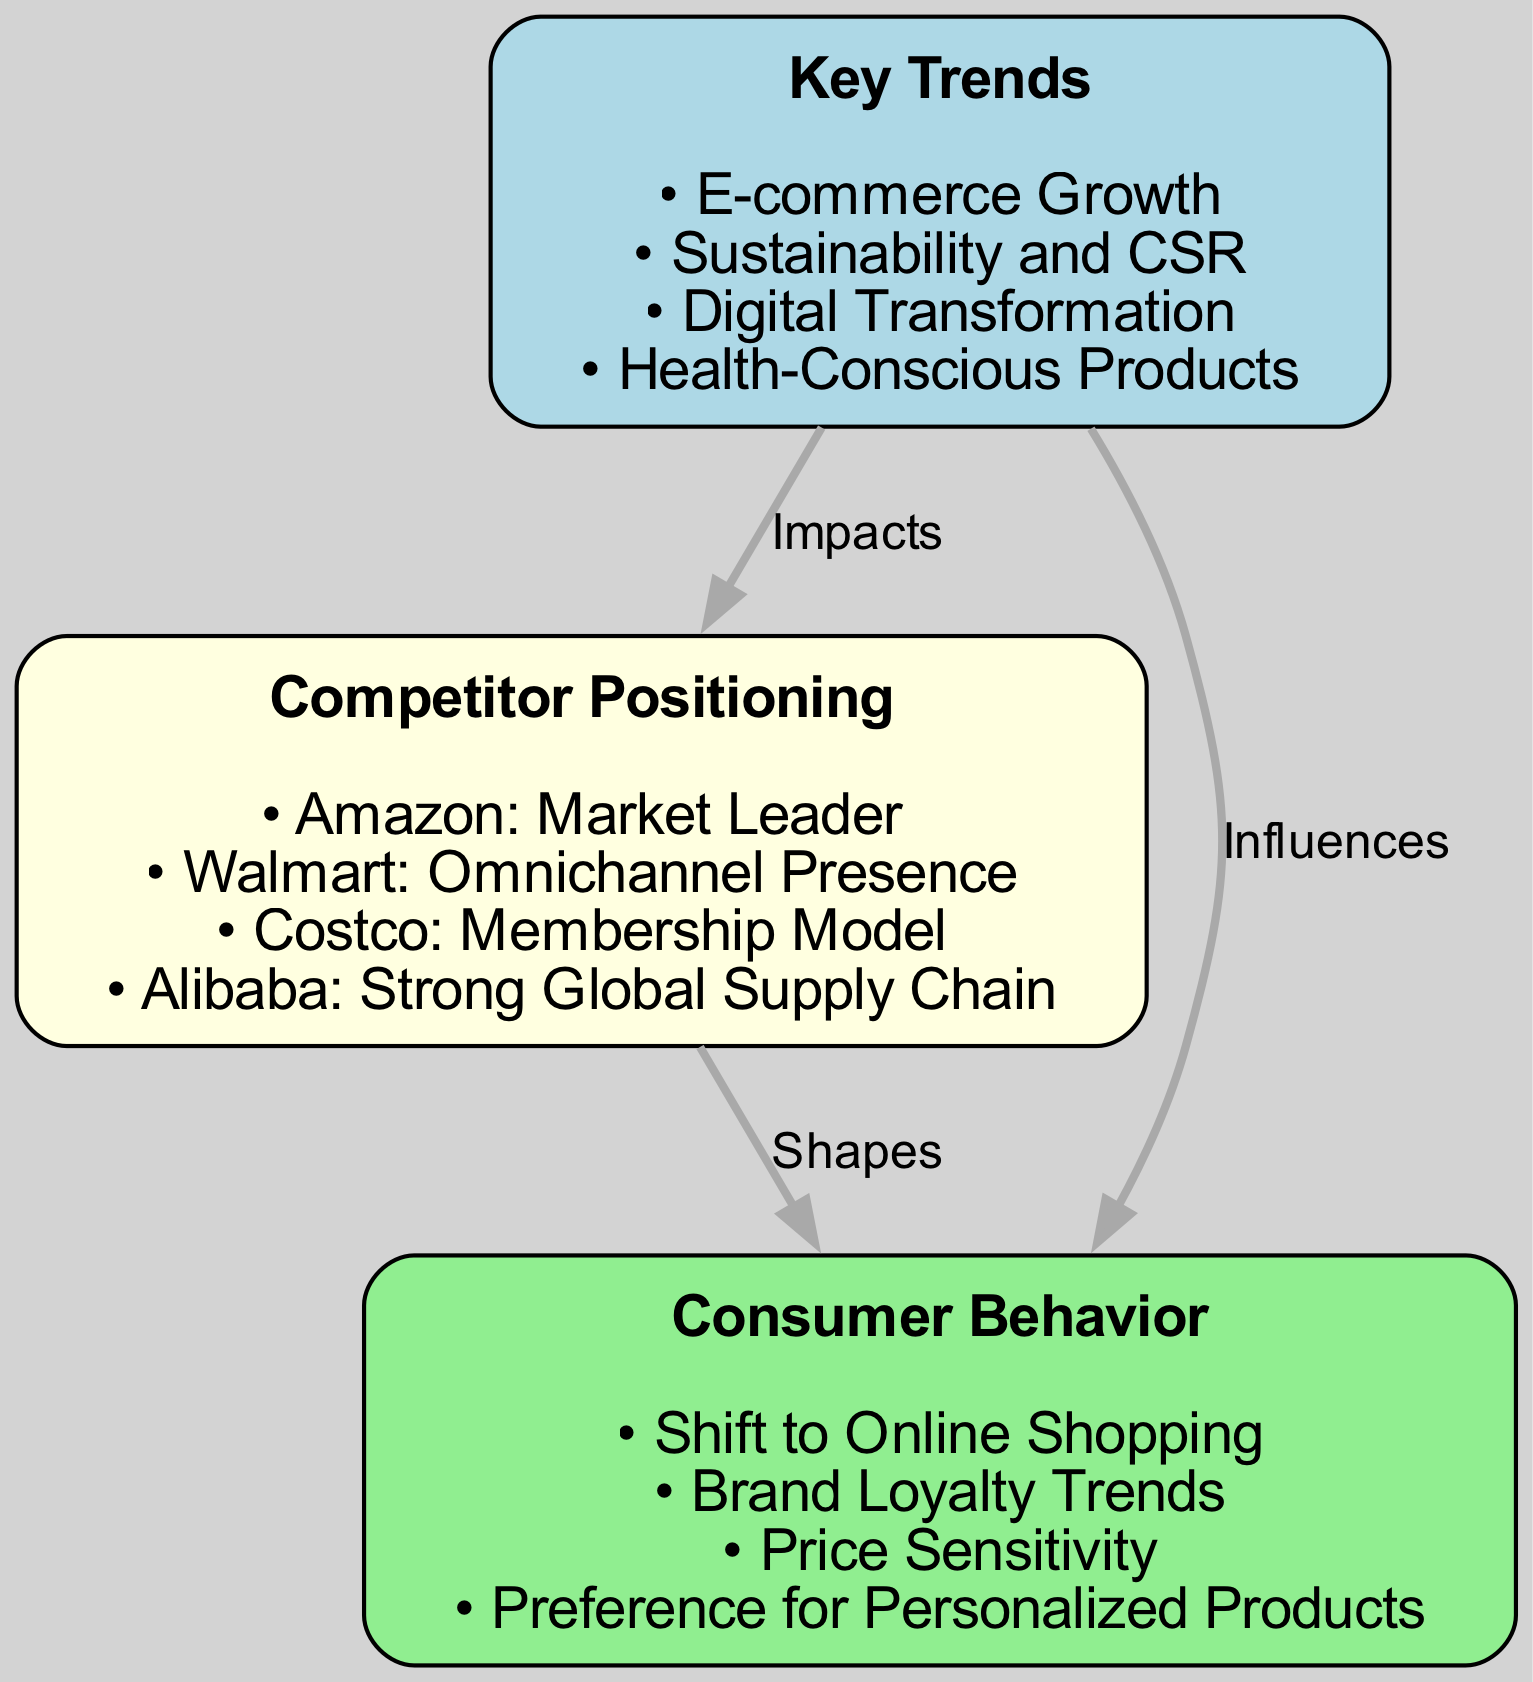What are the four key trends listed in the diagram? The diagram presents four key trends: E-commerce Growth, Sustainability and CSR, Digital Transformation, and Health-Conscious Products. These are directly listed under the "Key Trends" node.
Answer: E-commerce Growth, Sustainability and CSR, Digital Transformation, Health-Conscious Products Who is identified as the market leader in competitor positioning? According to the "Competitor Positioning" node in the diagram, Amazon is recognized as the market leader. This information is explicitly stated in the details of that node.
Answer: Amazon How many edges are present in the diagram? The diagram contains three edges that illustrate relationships between the nodes. This can be confirmed by counting the edges in the edges list provided.
Answer: 3 Which node influences consumer behavior according to the diagram? The diagram specifies that the "Key Trends" node influences the "Consumer Behavior" node, as indicated by the edge labeled "Influences" connecting them.
Answer: Key Trends What is the relationship between Competitor Positioning and Consumer Behavior? The relationship is characterized as "Shapes," indicating that the "Competitor Positioning" node helps to define or influence consumer behavior in the market. This interpretation comes from the edge that connects these two nodes.
Answer: Shapes What is one of the specific consumer behavior trends mentioned? The "Consumer Behavior" node lists several specific trends, one of which is "Shift to Online Shopping." This information can be found in the details under the "Consumer Behavior" node.
Answer: Shift to Online Shopping How does Key Trends impact Competitor Positioning? The diagram indicates that "Key Trends" node impacts the "Competitor Positioning" node, which is shown by the edge labeled "Impacts." This establishes a directional influence from trends to how competitors position themselves in the market.
Answer: Impacts What type of consumer products are increasingly favored according to the trends? One trend highlighted is the preference for "Personalized Products," showing an inclination among consumers towards customization, as stated in the "Consumer Behavior" node.
Answer: Personalized Products Which competitor is associated with a membership model? Costco is identified in the "Competitor Positioning" node as operating under a membership model, explicitly stated in the details provided for that node.
Answer: Costco 